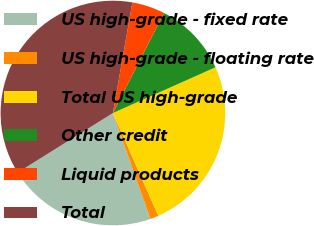<chart> <loc_0><loc_0><loc_500><loc_500><pie_chart><fcel>US high-grade - fixed rate<fcel>US high-grade - floating rate<fcel>Total US high-grade<fcel>Other credit<fcel>Liquid products<fcel>Total<nl><fcel>21.52%<fcel>1.21%<fcel>25.06%<fcel>10.8%<fcel>4.75%<fcel>36.66%<nl></chart> 